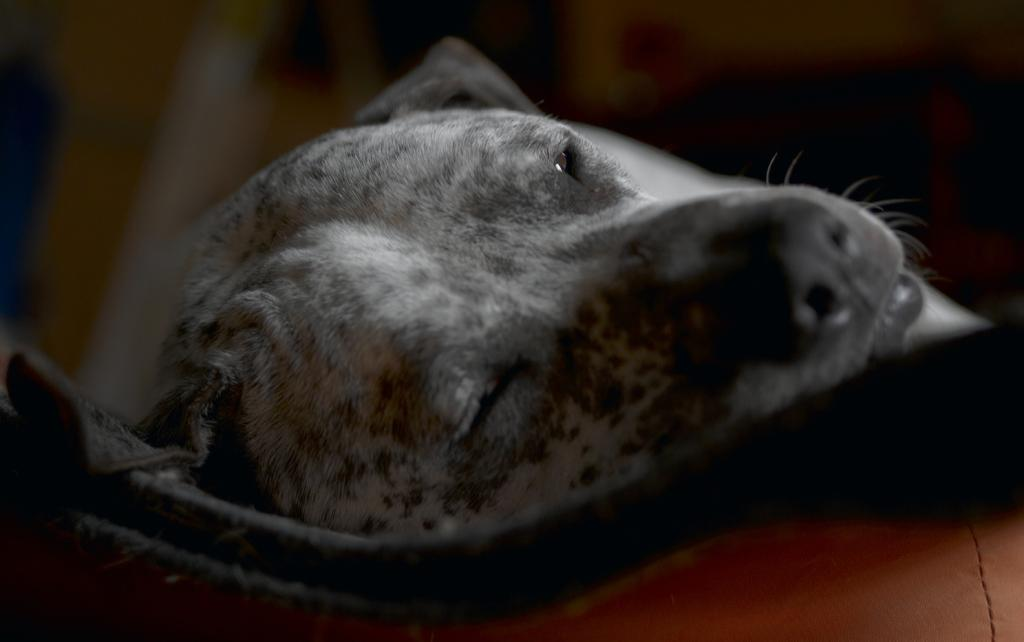What type of animal is in the image? There is a black dog in the image. What is the dog doing in the image? The dog is laying on a carpet. Where is the carpet located? The carpet is on a sofa. What type of stone can be seen in the dog's stomach in the image? There is no stone visible in the dog's stomach in the image, as the dog is a black dog laying on a carpet. 